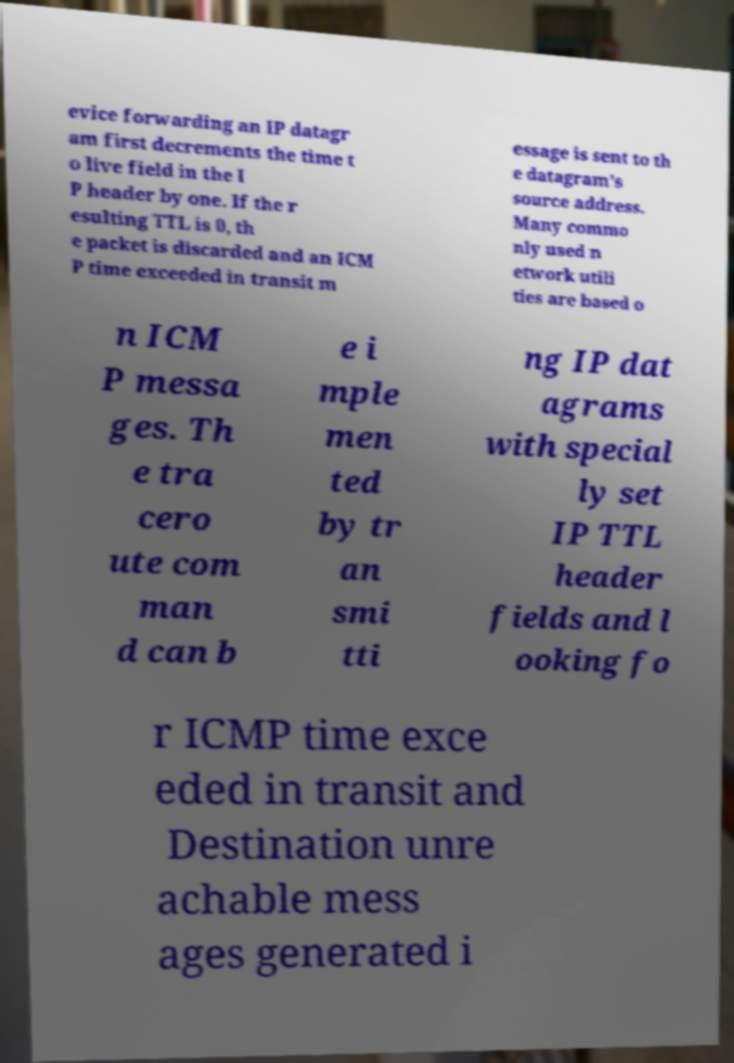For documentation purposes, I need the text within this image transcribed. Could you provide that? evice forwarding an IP datagr am first decrements the time t o live field in the I P header by one. If the r esulting TTL is 0, th e packet is discarded and an ICM P time exceeded in transit m essage is sent to th e datagram's source address. Many commo nly used n etwork utili ties are based o n ICM P messa ges. Th e tra cero ute com man d can b e i mple men ted by tr an smi tti ng IP dat agrams with special ly set IP TTL header fields and l ooking fo r ICMP time exce eded in transit and Destination unre achable mess ages generated i 